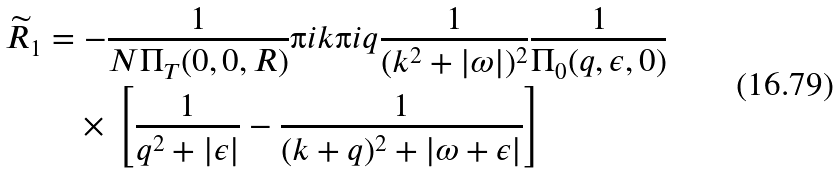Convert formula to latex. <formula><loc_0><loc_0><loc_500><loc_500>\widetilde { R } _ { 1 } & = - \frac { 1 } { N \Pi _ { T } ( 0 , 0 , R ) } \i i k \i i q \frac { 1 } { ( k ^ { 2 } + | \omega | ) ^ { 2 } } \frac { 1 } { \Pi _ { 0 } ( q , \epsilon , 0 ) } \\ & \quad \times \, \left [ \frac { 1 } { q ^ { 2 } + | \epsilon | } - \frac { 1 } { ( k + q ) ^ { 2 } + | \omega + \epsilon | } \right ]</formula> 